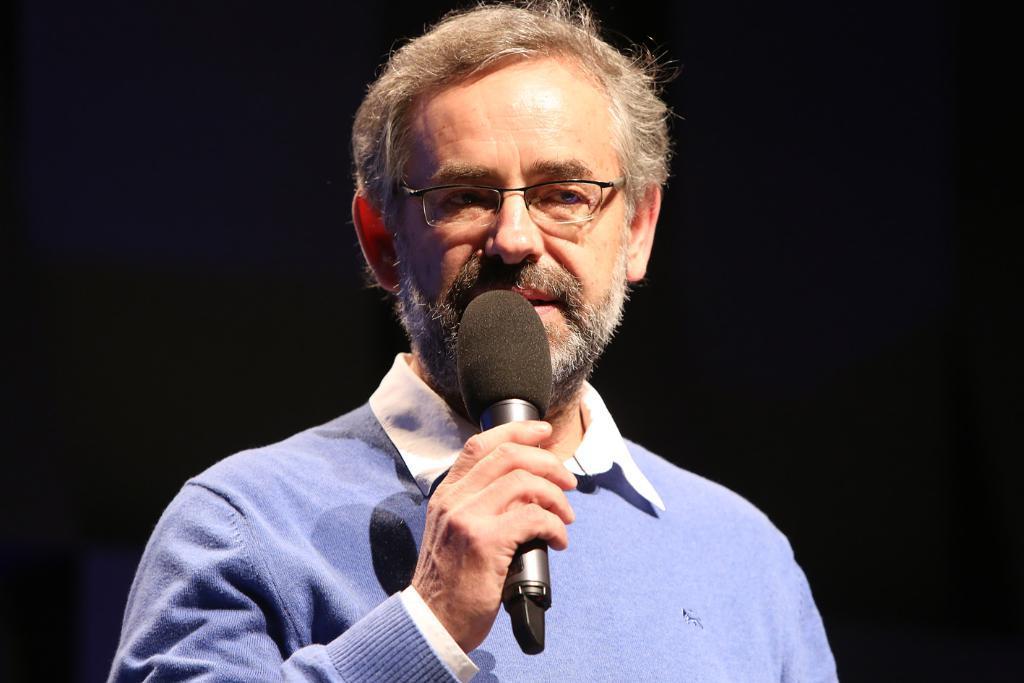Please provide a concise description of this image. In the center of the image we can see a man standing and holding a mic in his hand. 